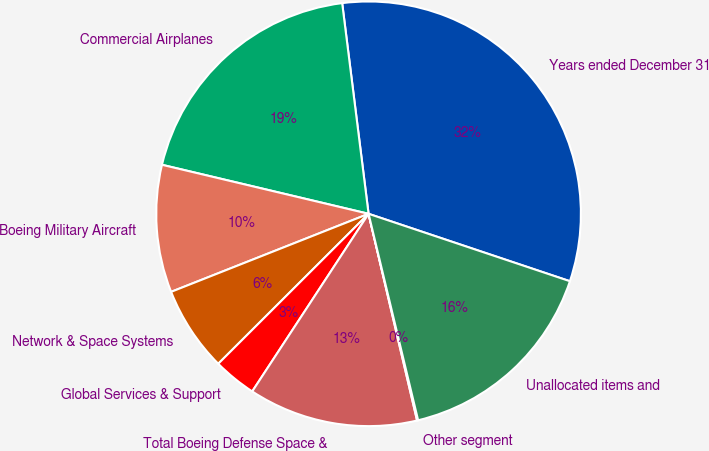Convert chart. <chart><loc_0><loc_0><loc_500><loc_500><pie_chart><fcel>Years ended December 31<fcel>Commercial Airplanes<fcel>Boeing Military Aircraft<fcel>Network & Space Systems<fcel>Global Services & Support<fcel>Total Boeing Defense Space &<fcel>Other segment<fcel>Unallocated items and<nl><fcel>32.13%<fcel>19.31%<fcel>9.7%<fcel>6.49%<fcel>3.29%<fcel>12.9%<fcel>0.08%<fcel>16.11%<nl></chart> 